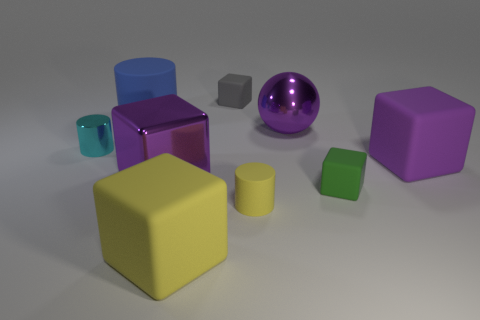Which objects in the scene could possibly serve as containers? The two cylindrical objects in the image appear to have an open top and thus could serve as containers. The larger one seems suitable for holding a substantial amount, while the smaller could contain less. 